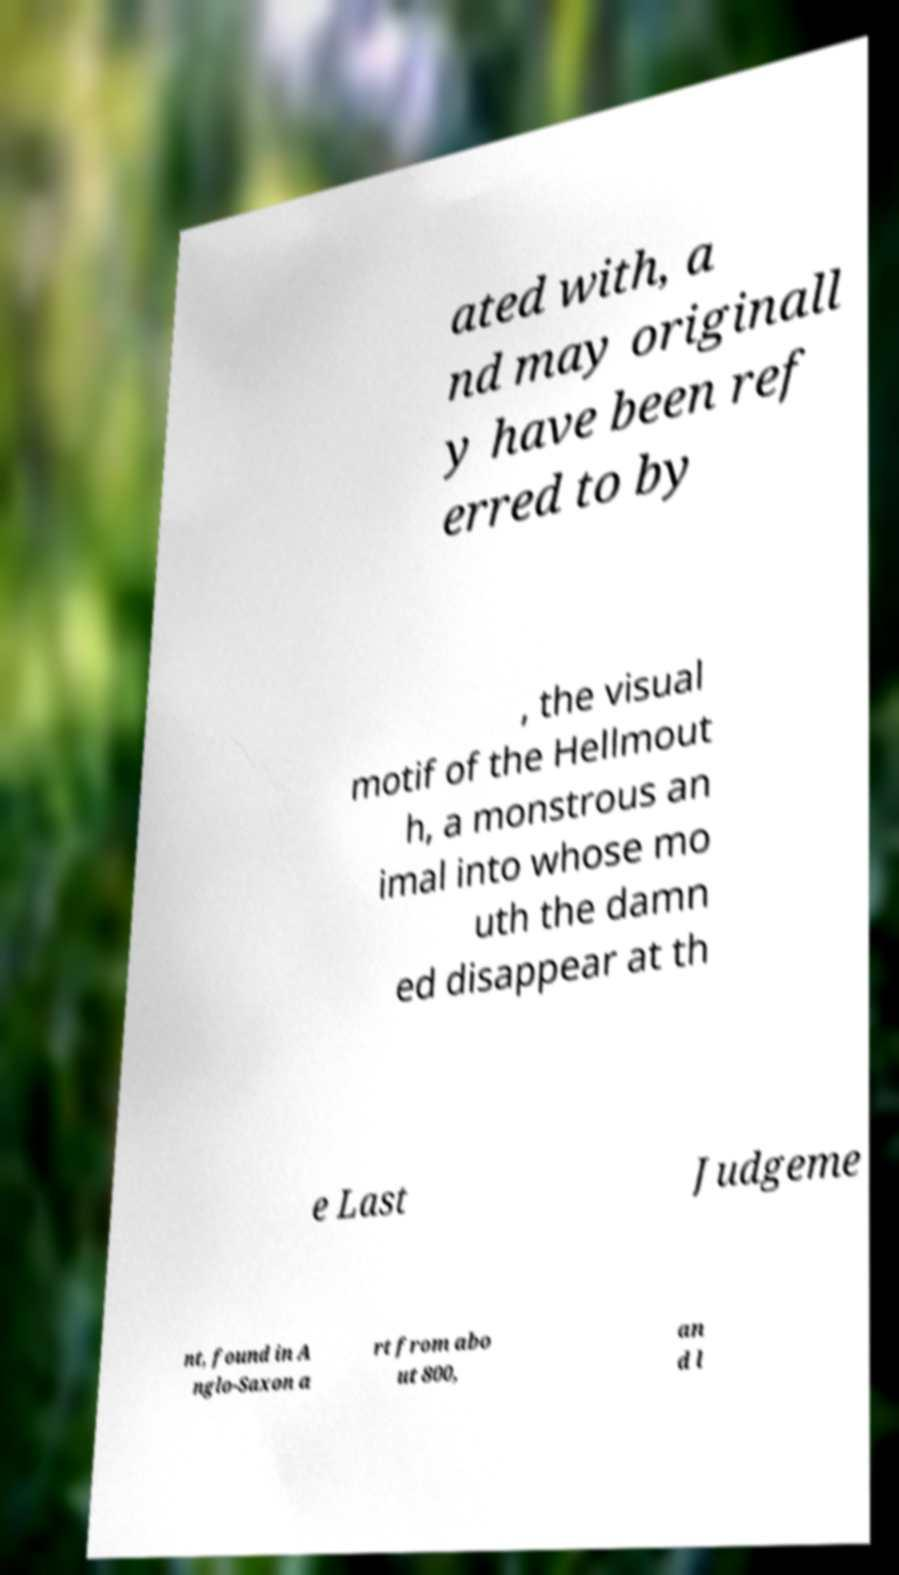I need the written content from this picture converted into text. Can you do that? ated with, a nd may originall y have been ref erred to by , the visual motif of the Hellmout h, a monstrous an imal into whose mo uth the damn ed disappear at th e Last Judgeme nt, found in A nglo-Saxon a rt from abo ut 800, an d l 